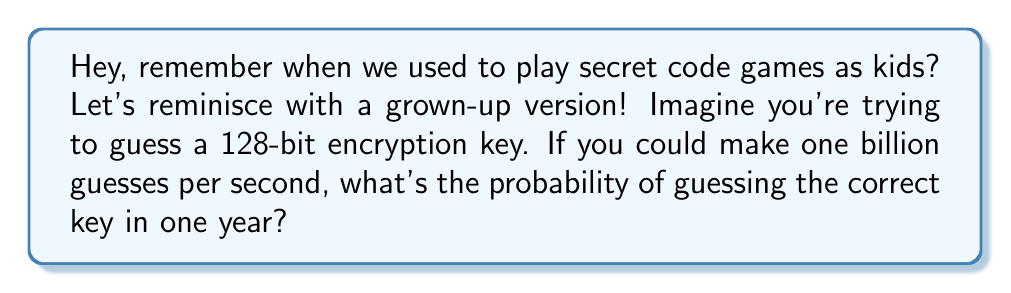Can you answer this question? Let's break this down step-by-step:

1) First, let's calculate the total number of possible 128-bit keys:
   $$ 2^{128} \text{ possible keys} $$

2) Now, let's calculate how many guesses we can make in a year:
   $$ 1 \text{ billion guesses/second} \times 60 \text{ seconds/minute} \times 60 \text{ minutes/hour} \times 24 \text{ hours/day} \times 365 \text{ days/year} $$
   $$ = 31,536,000,000,000,000 \text{ guesses/year} $$

3) The probability of guessing the correct key is the number of guesses we can make divided by the total number of possible keys:

   $$ P(\text{correct guess}) = \frac{\text{number of guesses}}{\text{total possible keys}} $$

   $$ = \frac{31,536,000,000,000,000}{2^{128}} $$

4) Let's calculate this:
   $$ \approx \frac{3.1536 \times 10^{16}}{3.4028 \times 10^{38}} $$
   $$ \approx 9.2676 \times 10^{-23} $$

This is an incredibly small probability!
Answer: $9.2676 \times 10^{-23}$ 